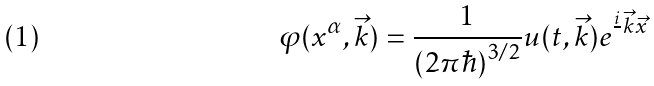Convert formula to latex. <formula><loc_0><loc_0><loc_500><loc_500>\varphi ( x ^ { \alpha } , \vec { k } ) = \frac { 1 } { ( 2 \pi \hbar { ) } ^ { 3 / 2 } } u ( t , \vec { k } ) e ^ { \frac { i } { } \vec { k } \vec { x } }</formula> 